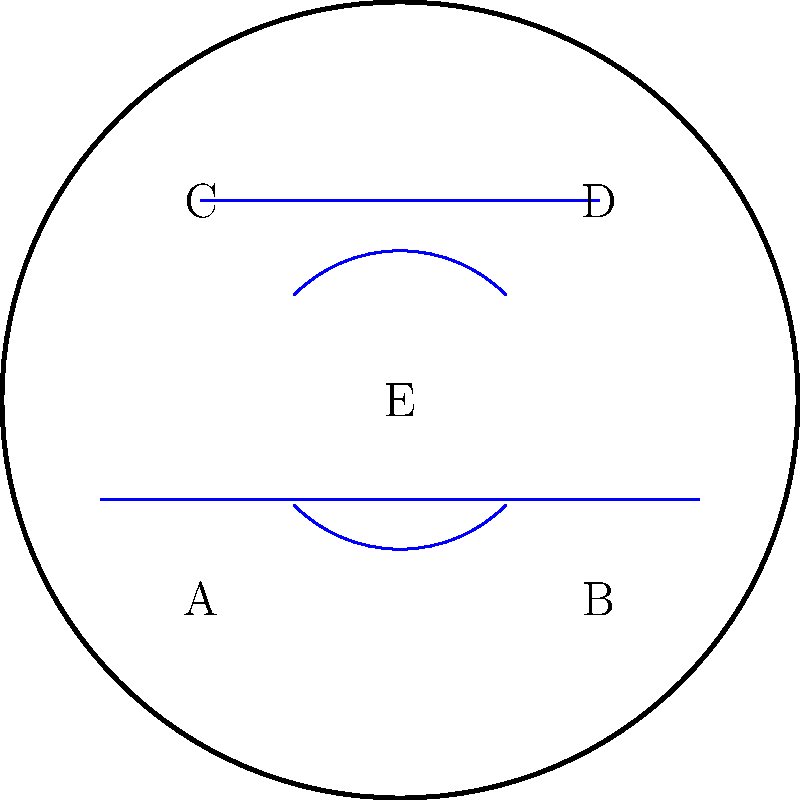Based on the topology of the infant playmat shown, which represents various textures and surfaces, how many distinct regions are created by the intersecting lines and curves? To determine the number of distinct regions in the playmat, we need to follow these steps:

1. Identify all intersection points:
   - The horizontal lines intersect the circle at 4 points
   - The arcs intersect the circle at 4 points
   - The horizontal lines intersect the arcs at 4 points

2. Count the regions:
   - The circle is initially divided into 4 quadrants by the two arcs
   - Each quadrant is further divided by a horizontal line
   - The central region (E) remains undivided

3. Sum up the regions:
   - 4 quadrants * 2 regions each = 8 regions
   - 1 central region
   
Therefore, the total number of distinct regions is $8 + 1 = 9$.

This analysis is crucial for a parent reviewing infant toys, as it demonstrates the variety of textures and surfaces that can stimulate a baby's tactile senses and promote sensory development.
Answer: 9 regions 